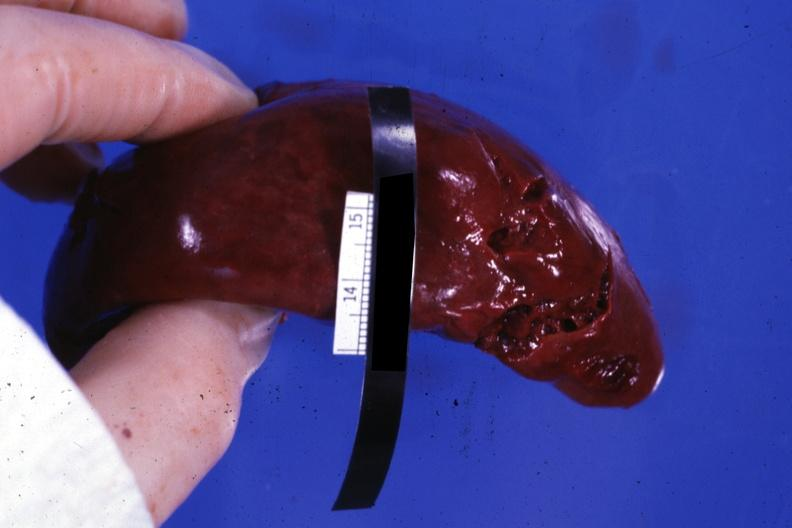how does this image show external view?
Answer the question using a single word or phrase. With several tears in capsule 